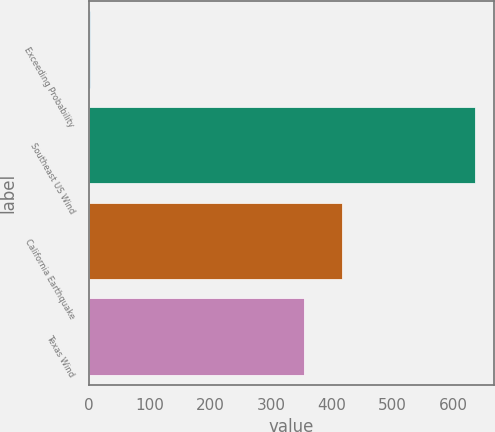Convert chart. <chart><loc_0><loc_0><loc_500><loc_500><bar_chart><fcel>Exceeding Probability<fcel>Southeast US Wind<fcel>California Earthquake<fcel>Texas Wind<nl><fcel>2<fcel>636<fcel>417.4<fcel>354<nl></chart> 